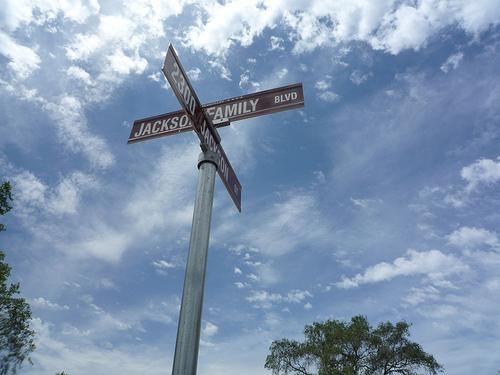Question: where was the picture taken?
Choices:
A. At an intersection in a city.
B. Alaska.
C. Las Vegas.
D. Washington D.C.
Answer with the letter. Answer: A Question: how many street signs are there?
Choices:
A. Three.
B. Two.
C. Four.
D. One.
Answer with the letter. Answer: B Question: what is in the sky?
Choices:
A. Planes.
B. Birds.
C. Drones.
D. Clouds.
Answer with the letter. Answer: D Question: what is the pole made of?
Choices:
A. Wood.
B. Bakelite.
C. Metal.
D. Glass.
Answer with the letter. Answer: C Question: what are the street signs on?
Choices:
A. The side of a building.
B. Hanging from an overhead wire.
C. Nailed to a tree.
D. The pole.
Answer with the letter. Answer: D 